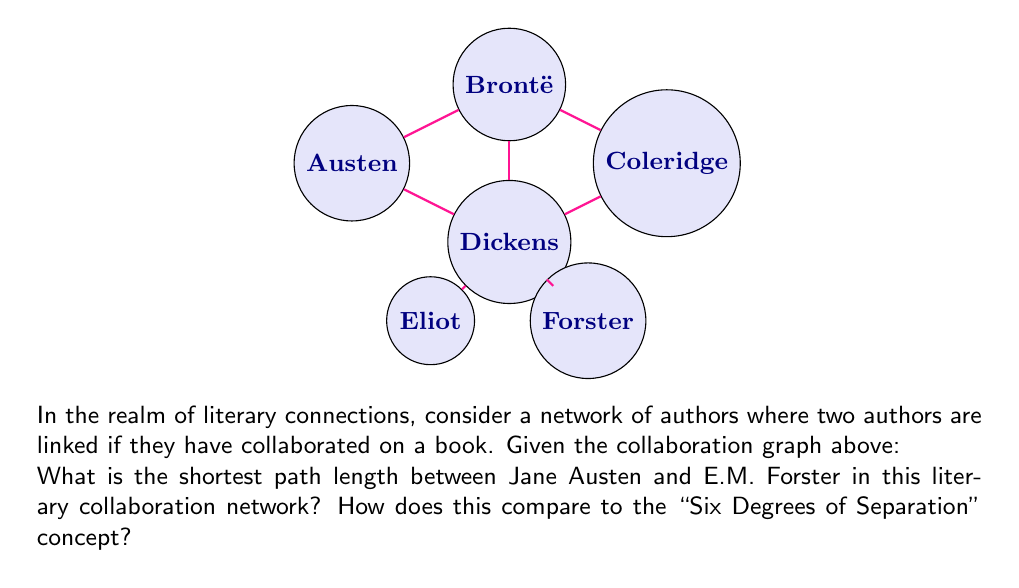Help me with this question. To solve this problem, we need to find the shortest path between Jane Austen and E.M. Forster in the given collaboration graph. Let's approach this step-by-step:

1) First, let's identify the nodes representing Austen and Forster:
   - Austen is represented by node A
   - Forster is represented by node F

2) Now, let's trace the shortest path from A to F:
   - A → B (Austen to Brontë)
   - B → D (Brontë to Dickens)
   - D → F (Dickens to Forster)

3) Counting the edges in this path:
   $$\text{Path length} = 3$$

4) Comparing to the "Six Degrees of Separation" concept:
   - The "Six Degrees of Separation" theory suggests that any two people in the world can be connected through a chain of no more than six social connections.
   - In this literary network, Austen and Forster are connected by only 3 degrees, which is well within the six degrees proposed by the theory.
   - This shorter path length could be attributed to the relatively small and interconnected nature of the literary world, especially among prominent authors.

5) Interpretation in the context of literature:
   This short path length suggests a tight-knit literary community, where even authors from different eras (like Austen and Forster) are closely connected through their contemporaries and successors. It illustrates the continuity and interconnectedness of literary traditions and influences.
Answer: 3 degrees 